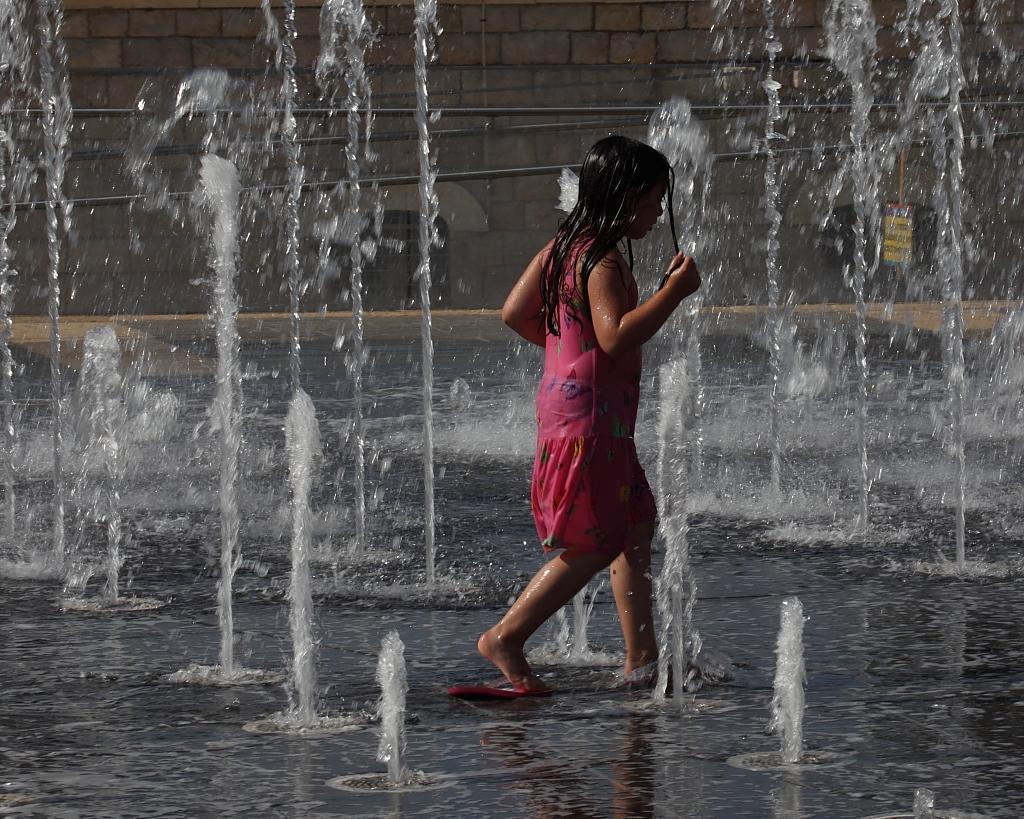Could you give a brief overview of what you see in this image? In the picture a girl is playing in the water fountain,she is wearing pink dress and behind the fountain there is a brick wall. 